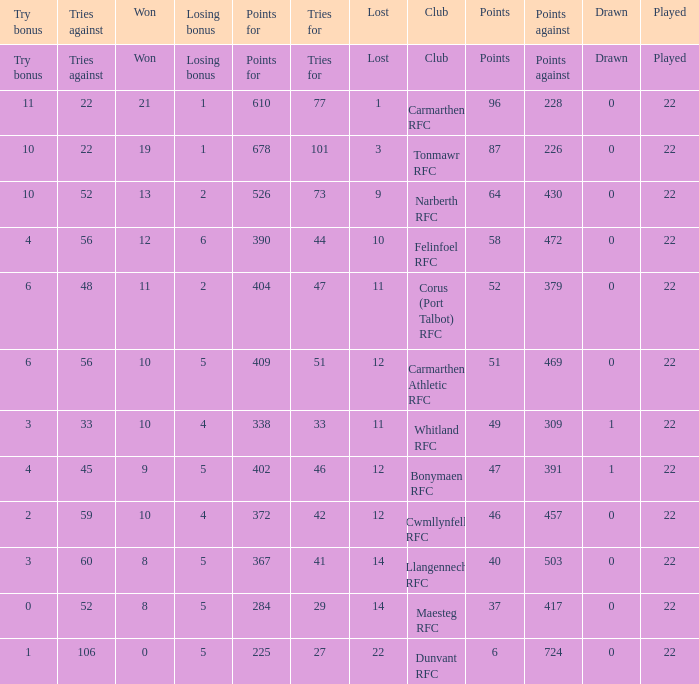Name the try bonus of points against at 430 10.0. 